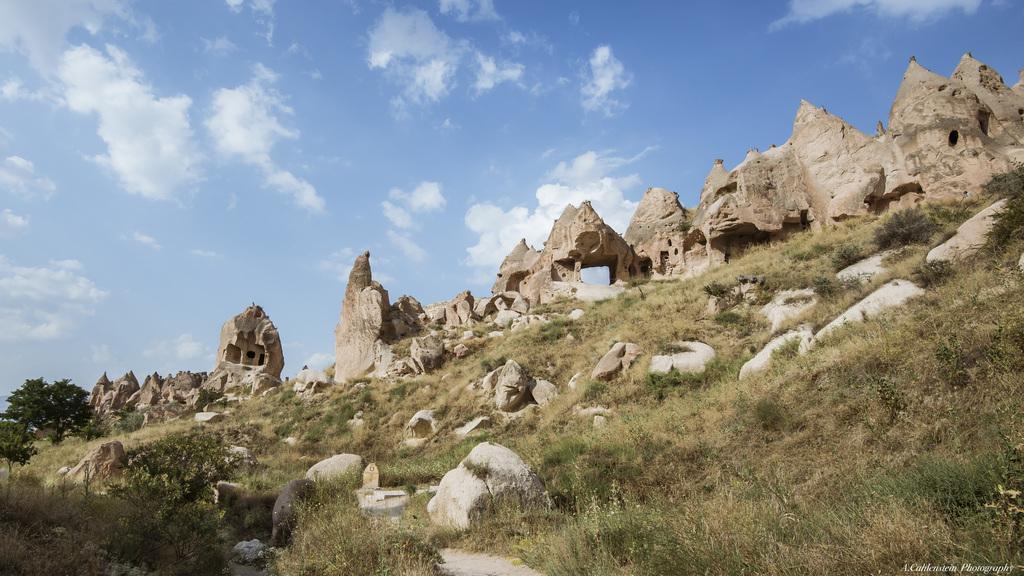Please provide a concise description of this image. In this image we can see grass, rocks, plants, trees, and ruins. In the background there is sky with clouds. 